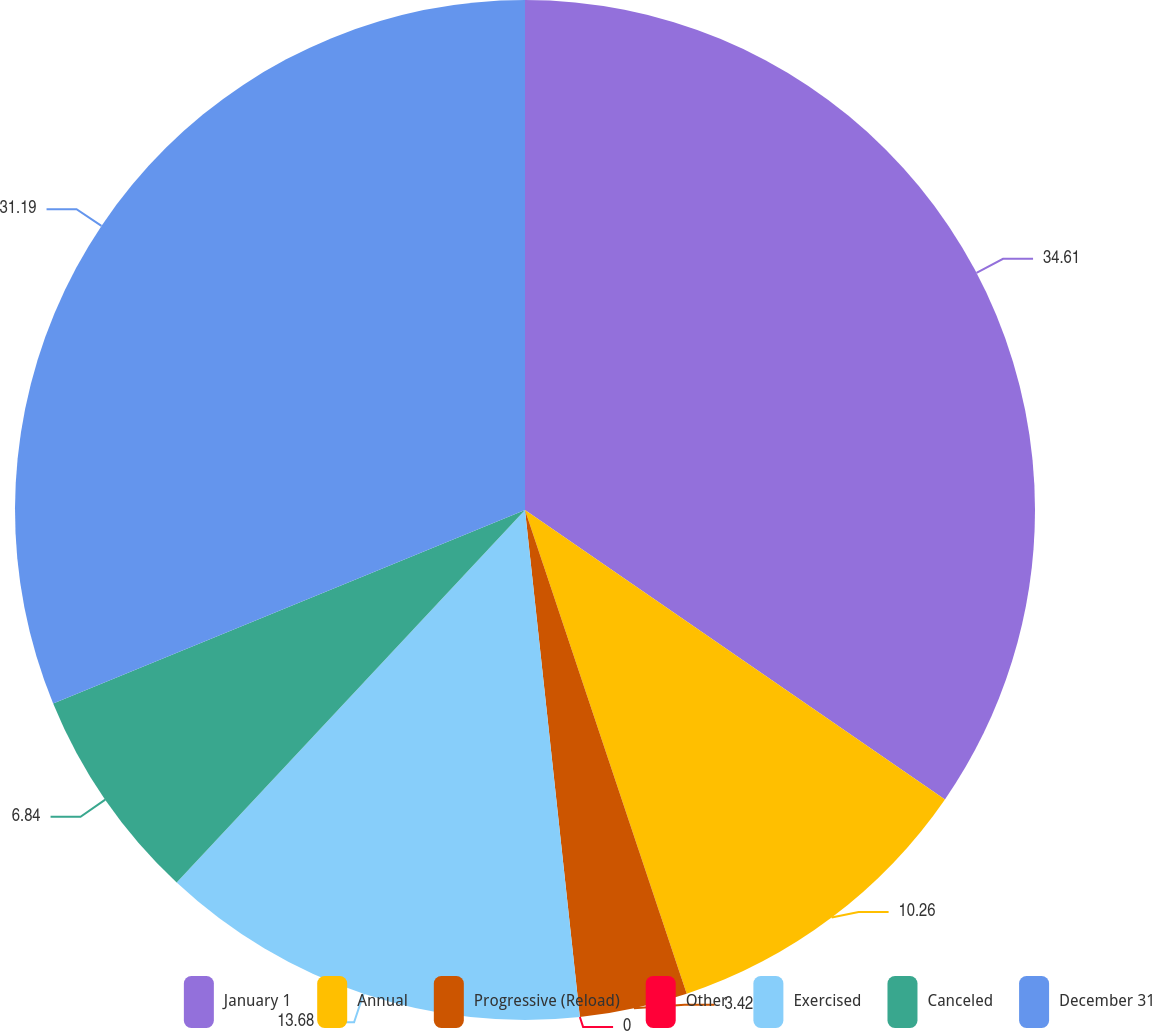Convert chart. <chart><loc_0><loc_0><loc_500><loc_500><pie_chart><fcel>January 1<fcel>Annual<fcel>Progressive (Reload)<fcel>Other<fcel>Exercised<fcel>Canceled<fcel>December 31<nl><fcel>34.6%<fcel>10.26%<fcel>3.42%<fcel>0.0%<fcel>13.68%<fcel>6.84%<fcel>31.19%<nl></chart> 